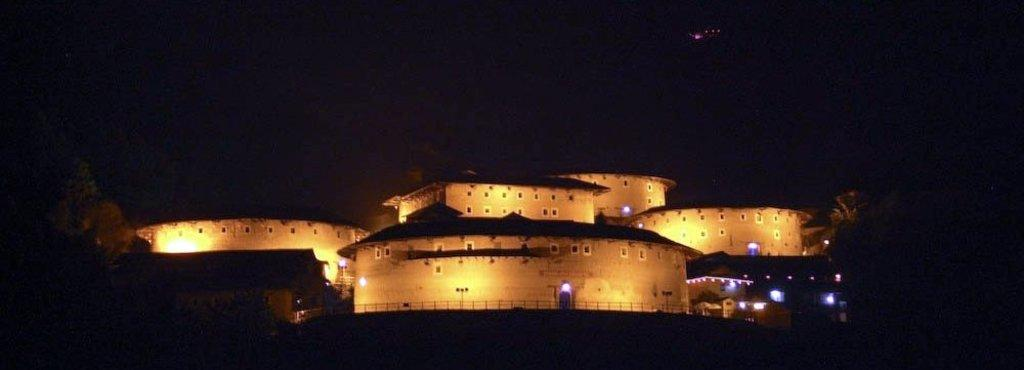What type of structures can be seen in the image? There are buildings in the image. What can be seen illuminating the buildings in the image? There are lights visible in the image. How would you describe the overall lighting condition in the image? The background of the image appears to be dark. Can you describe the environment where the person is observing the image? The area where the person is observing the image also appears to be dark. What type of plastic material is being used to calculate the height of the buildings in the image? There is no plastic material or calculator present in the image; it only shows buildings and lights. 